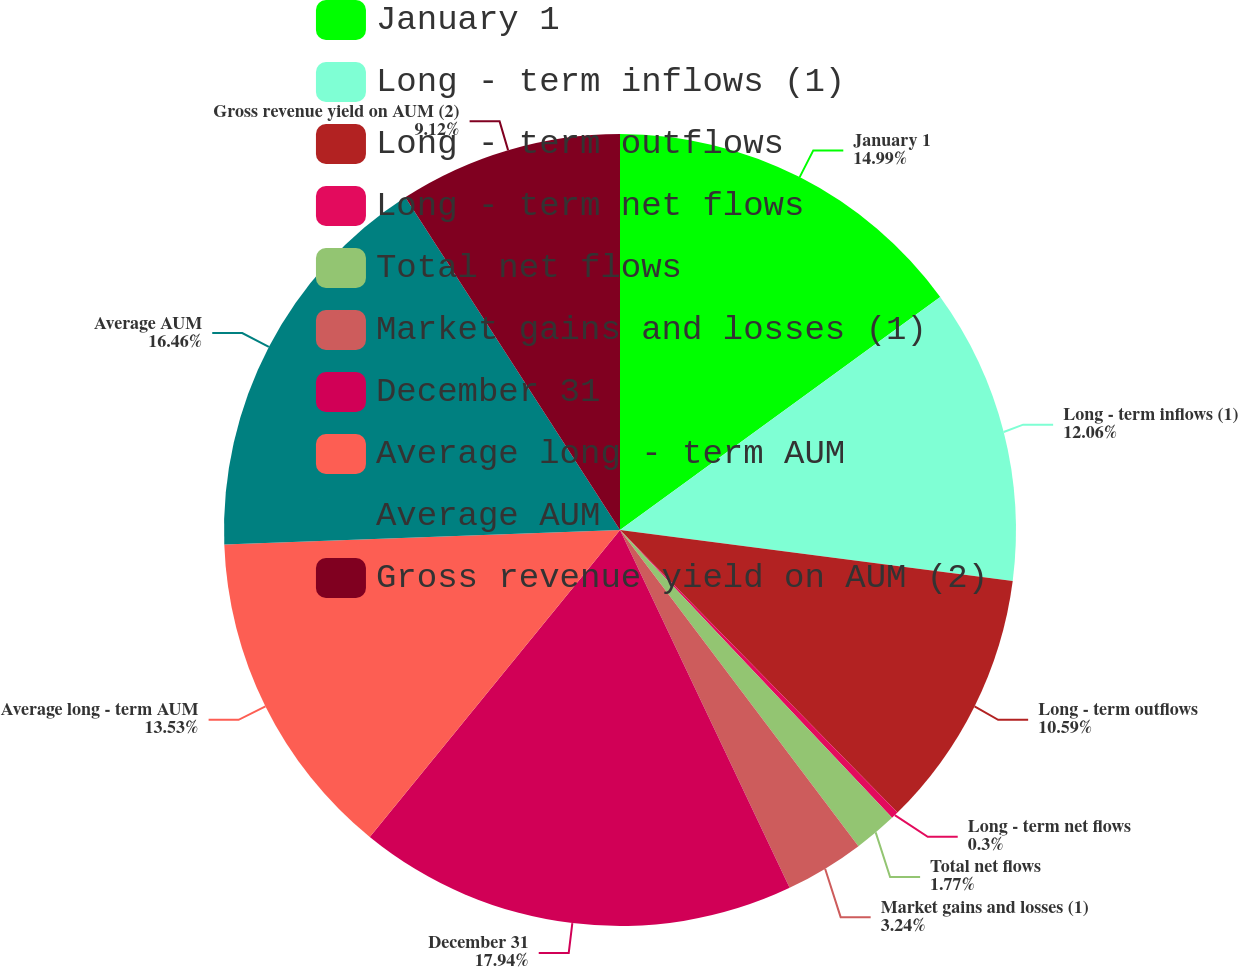Convert chart. <chart><loc_0><loc_0><loc_500><loc_500><pie_chart><fcel>January 1<fcel>Long - term inflows (1)<fcel>Long - term outflows<fcel>Long - term net flows<fcel>Total net flows<fcel>Market gains and losses (1)<fcel>December 31<fcel>Average long - term AUM<fcel>Average AUM<fcel>Gross revenue yield on AUM (2)<nl><fcel>14.99%<fcel>12.06%<fcel>10.59%<fcel>0.3%<fcel>1.77%<fcel>3.24%<fcel>17.93%<fcel>13.53%<fcel>16.46%<fcel>9.12%<nl></chart> 